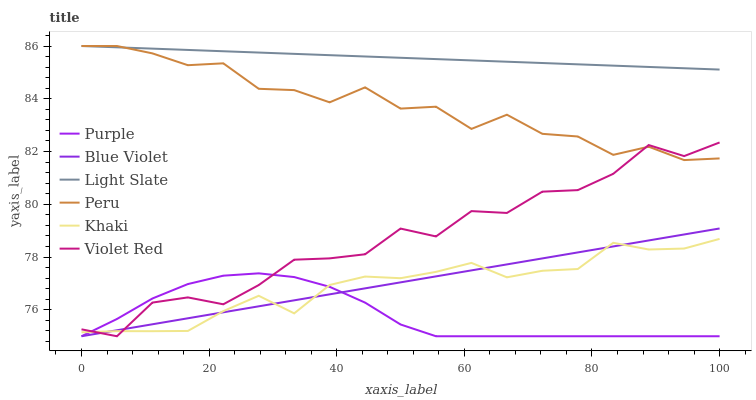Does Purple have the minimum area under the curve?
Answer yes or no. Yes. Does Light Slate have the maximum area under the curve?
Answer yes or no. Yes. Does Khaki have the minimum area under the curve?
Answer yes or no. No. Does Khaki have the maximum area under the curve?
Answer yes or no. No. Is Light Slate the smoothest?
Answer yes or no. Yes. Is Violet Red the roughest?
Answer yes or no. Yes. Is Khaki the smoothest?
Answer yes or no. No. Is Khaki the roughest?
Answer yes or no. No. Does Violet Red have the lowest value?
Answer yes or no. Yes. Does Khaki have the lowest value?
Answer yes or no. No. Does Peru have the highest value?
Answer yes or no. Yes. Does Khaki have the highest value?
Answer yes or no. No. Is Blue Violet less than Peru?
Answer yes or no. Yes. Is Light Slate greater than Blue Violet?
Answer yes or no. Yes. Does Khaki intersect Violet Red?
Answer yes or no. Yes. Is Khaki less than Violet Red?
Answer yes or no. No. Is Khaki greater than Violet Red?
Answer yes or no. No. Does Blue Violet intersect Peru?
Answer yes or no. No. 